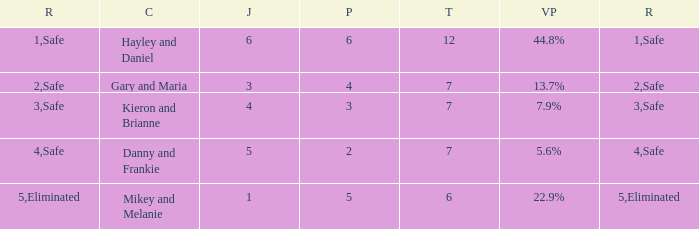What was the maximum rank for the vote percentage of 5.6% 4.0. 